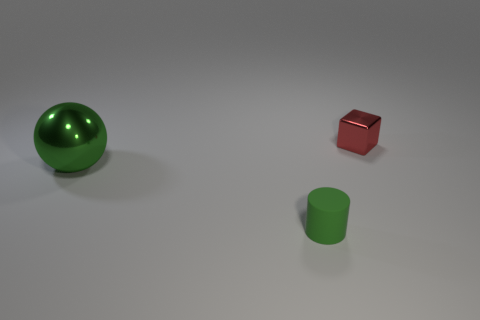Add 1 tiny cyan metal spheres. How many objects exist? 4 Subtract 0 yellow cylinders. How many objects are left? 3 Subtract all cylinders. How many objects are left? 2 Subtract all brown spheres. Subtract all cyan cylinders. How many spheres are left? 1 Subtract all large cyan shiny cylinders. Subtract all small metallic blocks. How many objects are left? 2 Add 2 large green balls. How many large green balls are left? 3 Add 2 green objects. How many green objects exist? 4 